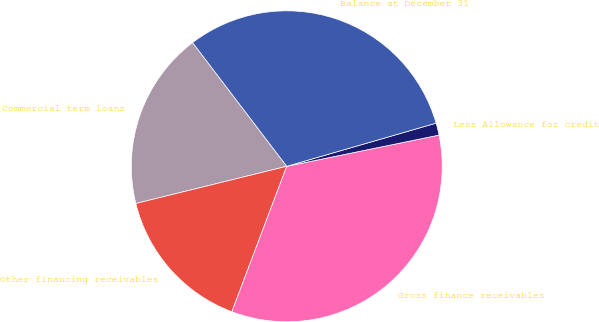Convert chart. <chart><loc_0><loc_0><loc_500><loc_500><pie_chart><fcel>Commercial term loans<fcel>Other financing receivables<fcel>Gross finance receivables<fcel>Less Allowance for credit<fcel>Balance at December 31<nl><fcel>18.49%<fcel>15.41%<fcel>33.96%<fcel>1.26%<fcel>30.88%<nl></chart> 